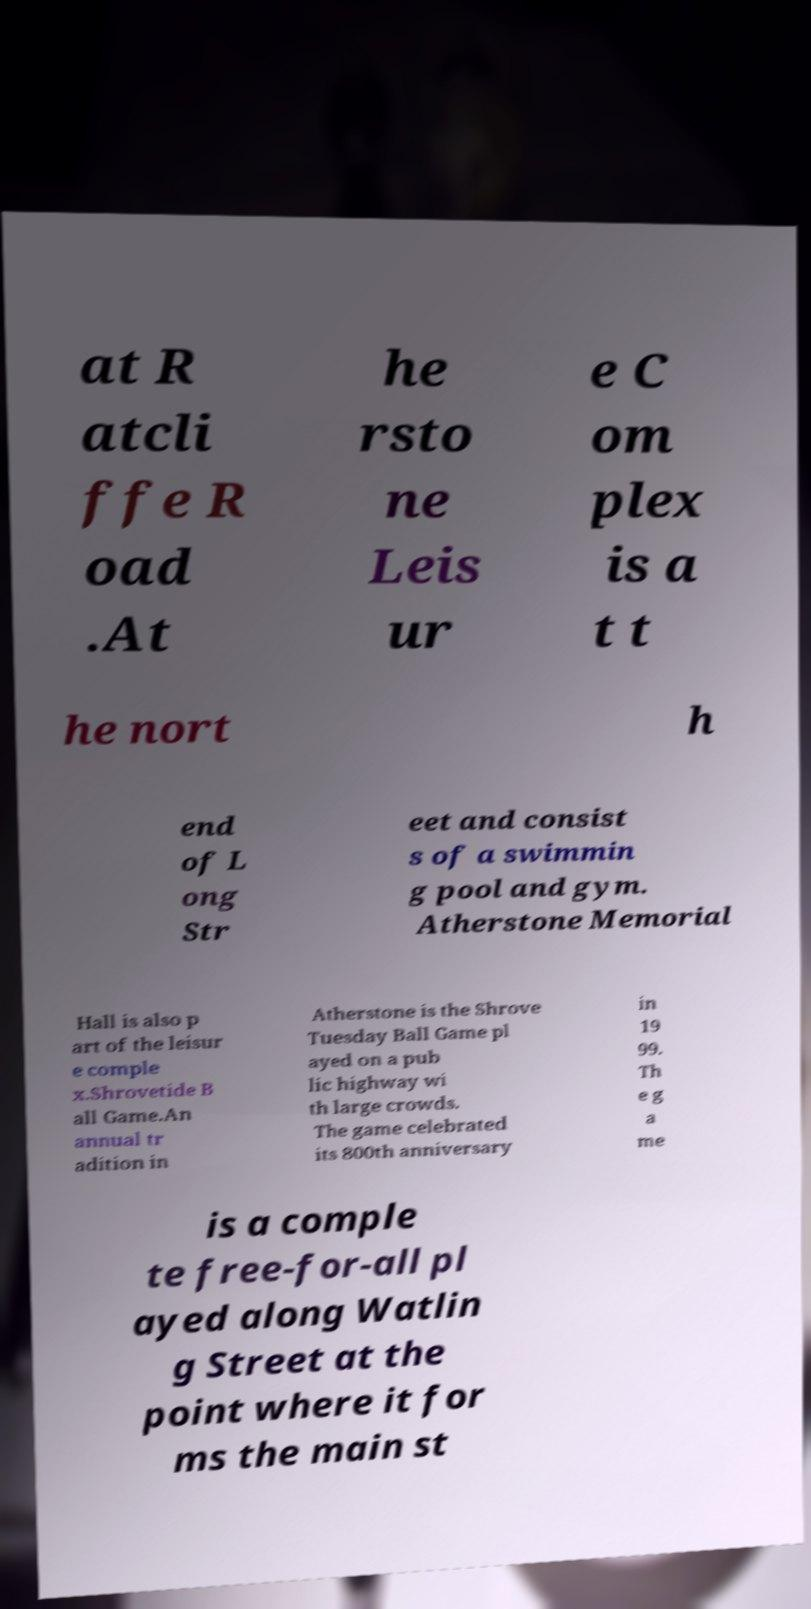Could you assist in decoding the text presented in this image and type it out clearly? at R atcli ffe R oad .At he rsto ne Leis ur e C om plex is a t t he nort h end of L ong Str eet and consist s of a swimmin g pool and gym. Atherstone Memorial Hall is also p art of the leisur e comple x.Shrovetide B all Game.An annual tr adition in Atherstone is the Shrove Tuesday Ball Game pl ayed on a pub lic highway wi th large crowds. The game celebrated its 800th anniversary in 19 99. Th e g a me is a comple te free-for-all pl ayed along Watlin g Street at the point where it for ms the main st 